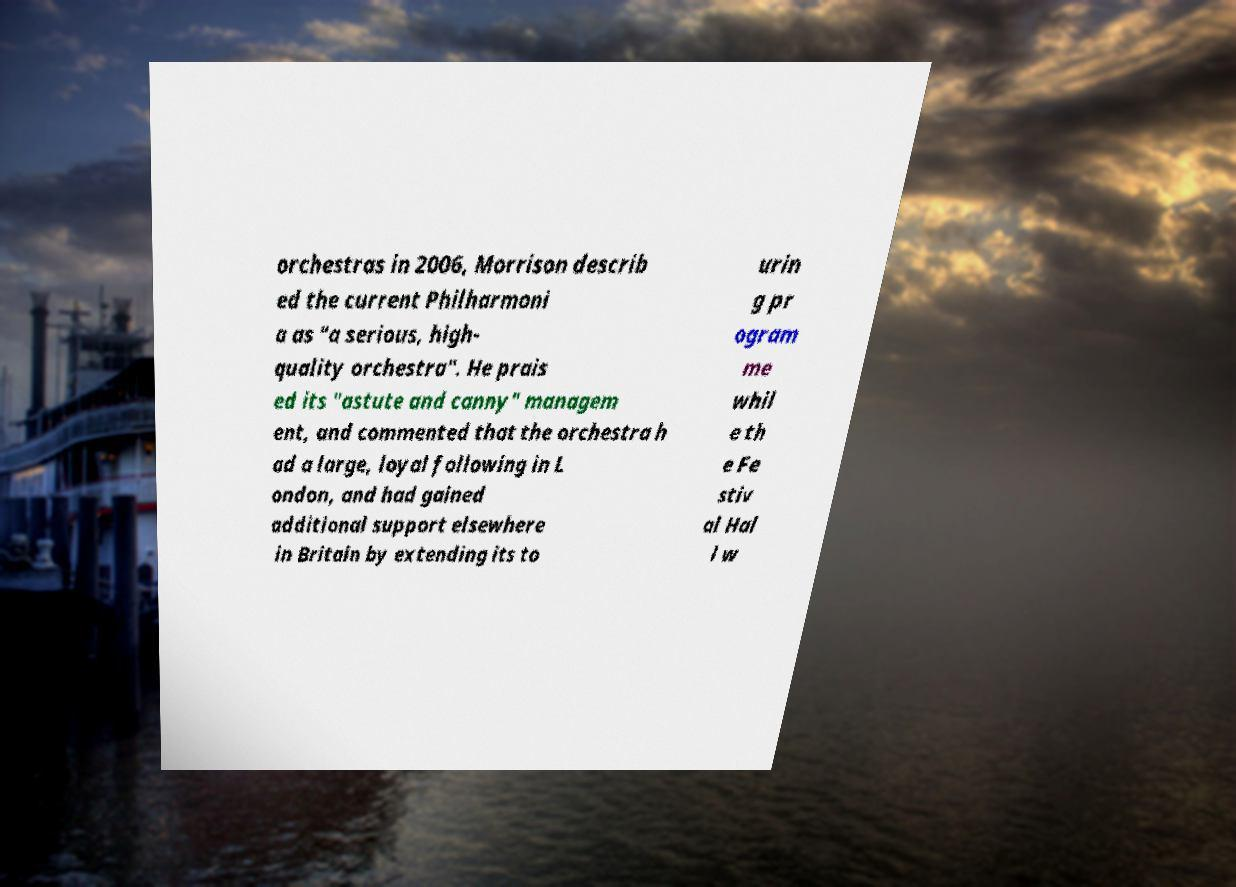Please identify and transcribe the text found in this image. orchestras in 2006, Morrison describ ed the current Philharmoni a as "a serious, high- quality orchestra". He prais ed its "astute and canny" managem ent, and commented that the orchestra h ad a large, loyal following in L ondon, and had gained additional support elsewhere in Britain by extending its to urin g pr ogram me whil e th e Fe stiv al Hal l w 